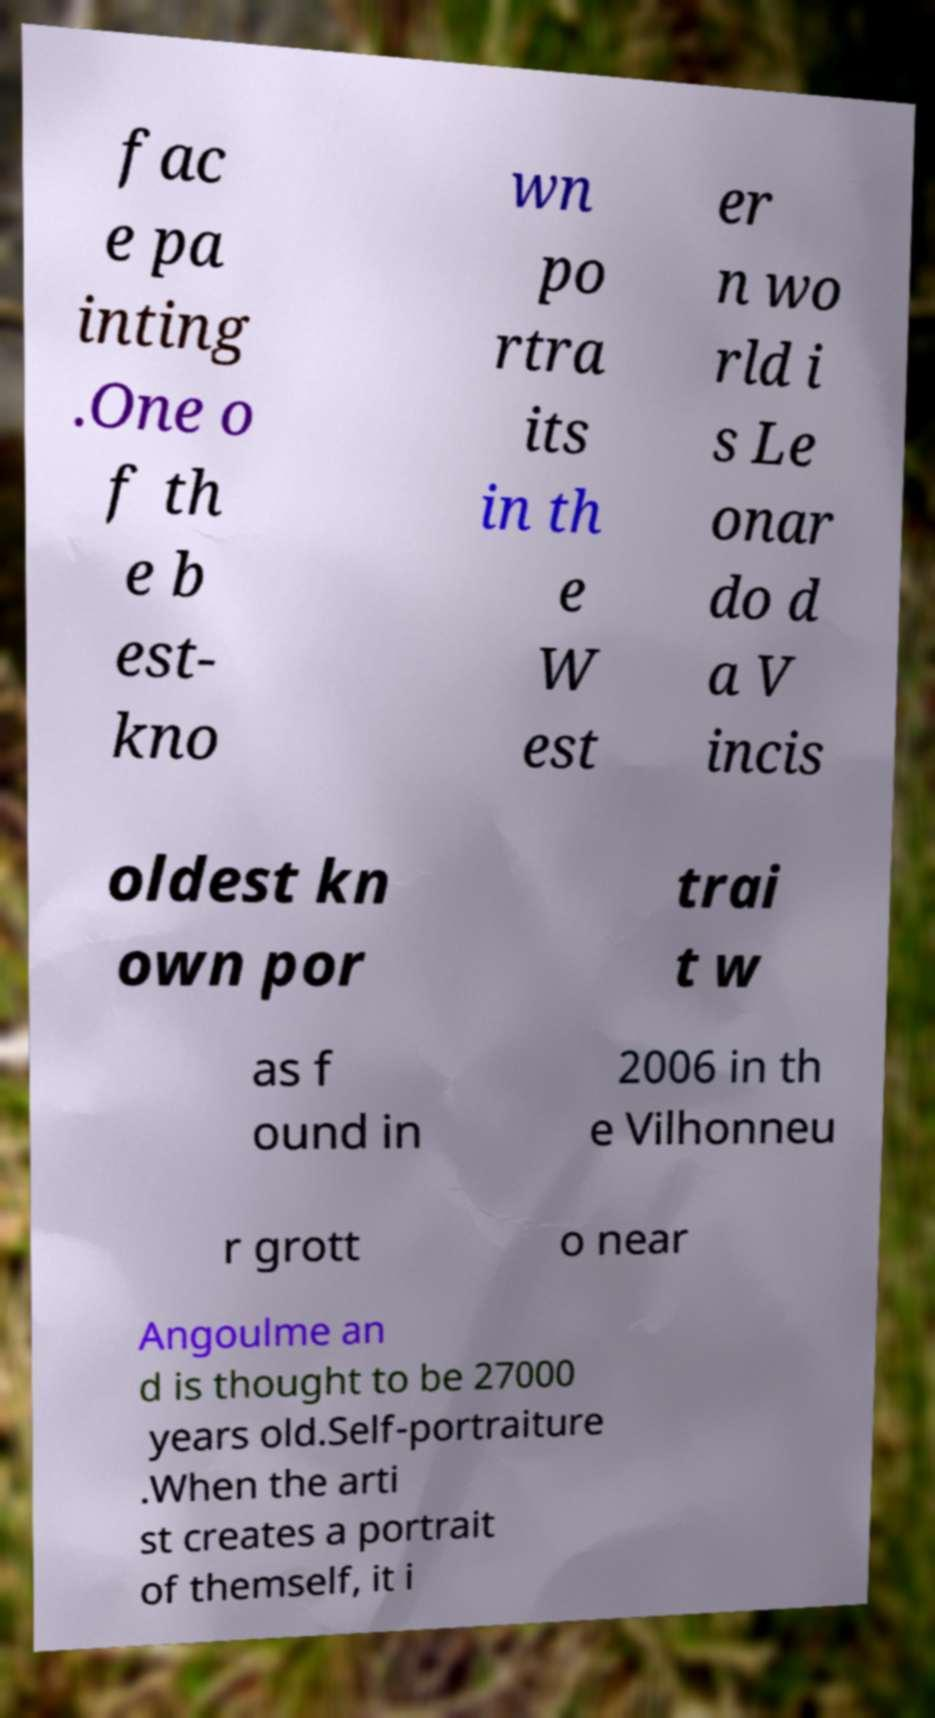For documentation purposes, I need the text within this image transcribed. Could you provide that? fac e pa inting .One o f th e b est- kno wn po rtra its in th e W est er n wo rld i s Le onar do d a V incis oldest kn own por trai t w as f ound in 2006 in th e Vilhonneu r grott o near Angoulme an d is thought to be 27000 years old.Self-portraiture .When the arti st creates a portrait of themself, it i 